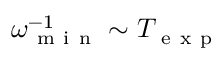Convert formula to latex. <formula><loc_0><loc_0><loc_500><loc_500>\omega _ { m i n } ^ { - 1 } \sim T _ { e x p }</formula> 